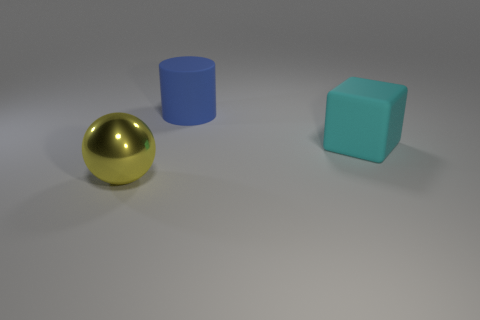Add 2 tiny red matte cylinders. How many objects exist? 5 Add 3 large cyan matte blocks. How many large cyan matte blocks are left? 4 Add 3 gray rubber objects. How many gray rubber objects exist? 3 Subtract 0 brown cubes. How many objects are left? 3 Subtract all balls. How many objects are left? 2 Subtract all blue cylinders. Subtract all blue objects. How many objects are left? 1 